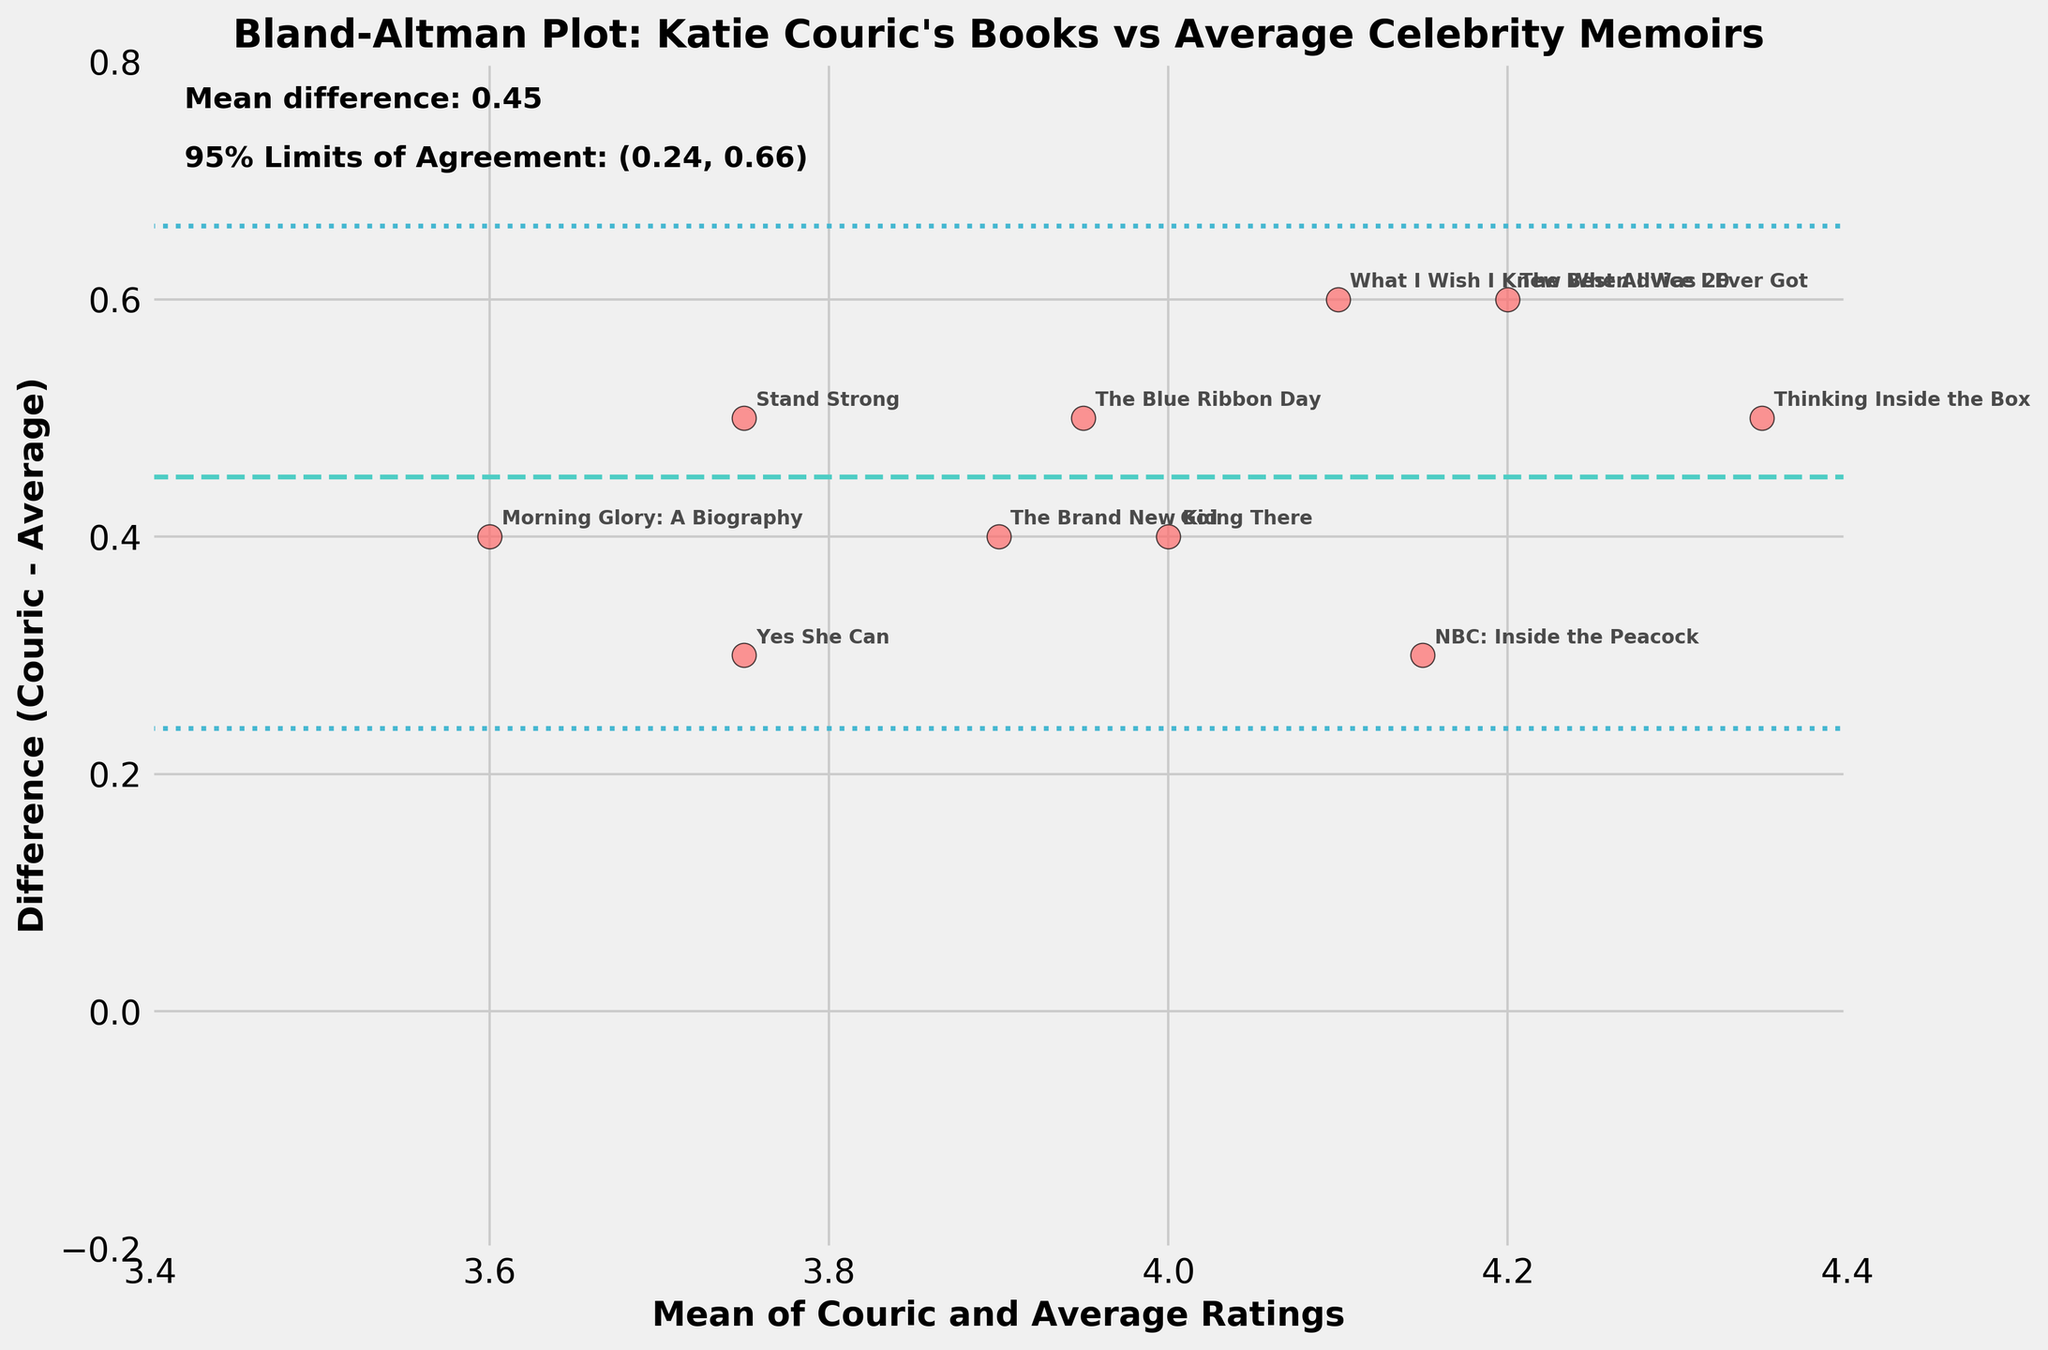What is the title of the plot? The title is displayed at the top of the plot. It reads, "Bland-Altman Plot: Katie Couric's Books vs Average Celebrity Memoirs".
Answer: Bland-Altman Plot: Katie Couric's Books vs Average Celebrity Memoirs What is the mean difference between Katie Couric's ratings and the average celebrity memoir ratings? The mean difference is mentioned in the text within the plot in the upper left corner. It states, "Mean difference: 0.42".
Answer: 0.42 What do the x and y axes represent? The x-axis represents the mean of Katie Couric's ratings and the average ratings for celebrity memoirs, and the y-axis represents the difference between Katie Couric's ratings and the average ratings for celebrity memoirs.
Answer: x-axis: Mean of Couric and Average Ratings; y-axis: Difference (Couric - Average) Which book has the highest difference in ratings between Katie Couric's ratings and the average celebrity memoir ratings? By observing the points on the plot, "Thinking Inside the Box" has the largest positive difference on the y-axis.
Answer: Thinking Inside the Box What do the dashed lines on the plot signify? The dashed line in the middle represents the mean difference, and the dotted lines above and below it are the 95% limits of agreement.
Answer: Mean difference and 95% limits of agreement How many data points lie within the 95% limits of agreement? By counting the points between the upper and lower dotted lines on the y-axis, all 10 data points lie within the 95% limits of agreement.
Answer: 10 What are the 95% limits of agreement for the plot? The 95% limits of agreement are mentioned in the text within the plot in the upper left corner. It states, "95% Limits of Agreement: (0.05, 0.79)".
Answer: (0.05, 0.79) Which book's rating by Katie Couric is closest to the average celebrity memoir rating? By observing the points closest to the x-axis (difference close to 0), "Morning Glory: A Biography" has a difference nearest to 0.
Answer: Morning Glory: A Biography 